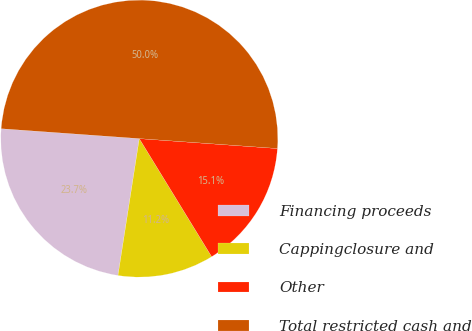Convert chart to OTSL. <chart><loc_0><loc_0><loc_500><loc_500><pie_chart><fcel>Financing proceeds<fcel>Cappingclosure and<fcel>Other<fcel>Total restricted cash and<nl><fcel>23.68%<fcel>11.21%<fcel>15.11%<fcel>50.0%<nl></chart> 